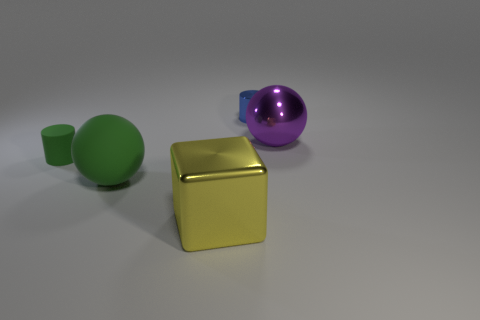What number of large things are left of the small object right of the big yellow block?
Offer a very short reply. 2. What number of metal things are in front of the purple shiny object?
Your answer should be very brief. 1. There is a small thing on the right side of the small thing that is in front of the purple thing behind the large yellow thing; what color is it?
Ensure brevity in your answer.  Blue. Do the rubber object that is behind the big green rubber ball and the large shiny object in front of the purple sphere have the same color?
Keep it short and to the point. No. What shape is the big metallic object on the right side of the small cylinder right of the small green matte object?
Your response must be concise. Sphere. Are there any rubber cylinders of the same size as the blue metallic cylinder?
Provide a succinct answer. Yes. How many purple shiny objects are the same shape as the big matte object?
Keep it short and to the point. 1. Is the number of balls that are behind the small shiny thing the same as the number of green rubber things behind the tiny green thing?
Offer a terse response. Yes. Are any blocks visible?
Give a very brief answer. Yes. What size is the sphere left of the metallic object left of the small metal cylinder that is behind the yellow metal object?
Your answer should be compact. Large. 